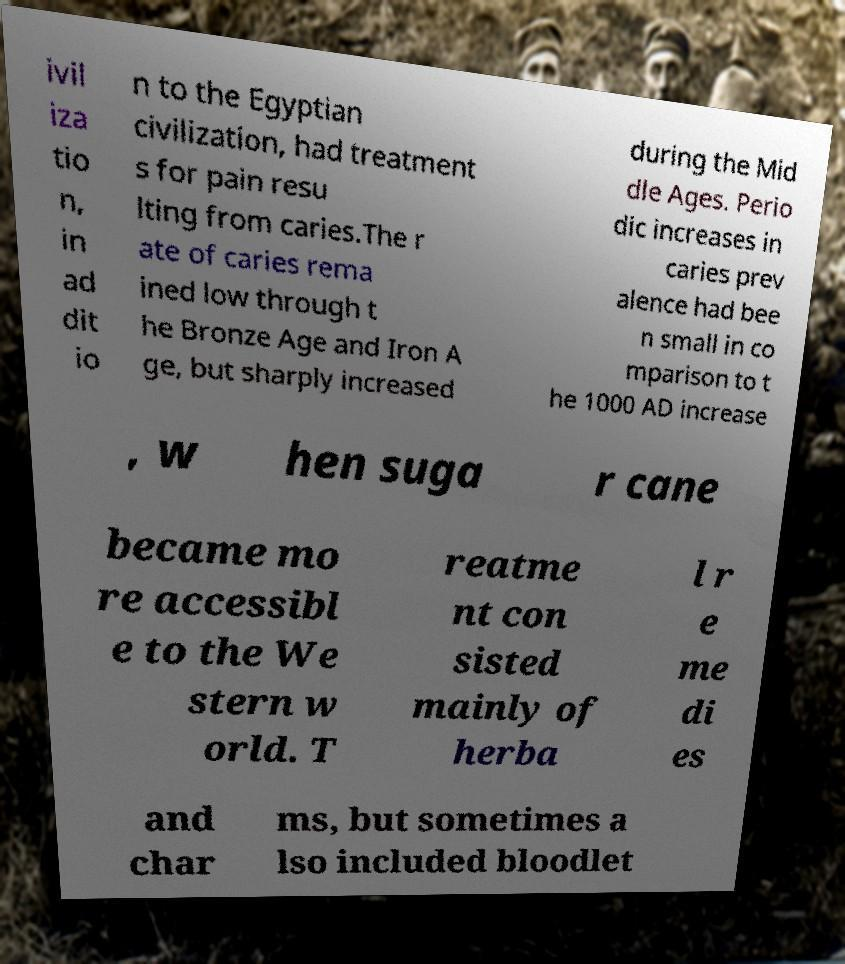There's text embedded in this image that I need extracted. Can you transcribe it verbatim? ivil iza tio n, in ad dit io n to the Egyptian civilization, had treatment s for pain resu lting from caries.The r ate of caries rema ined low through t he Bronze Age and Iron A ge, but sharply increased during the Mid dle Ages. Perio dic increases in caries prev alence had bee n small in co mparison to t he 1000 AD increase , w hen suga r cane became mo re accessibl e to the We stern w orld. T reatme nt con sisted mainly of herba l r e me di es and char ms, but sometimes a lso included bloodlet 